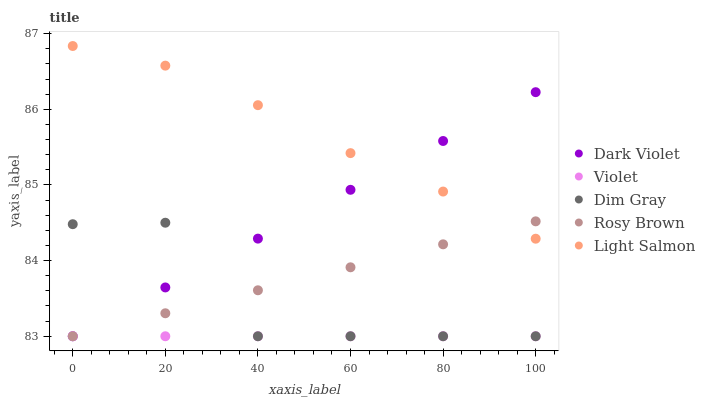Does Violet have the minimum area under the curve?
Answer yes or no. Yes. Does Light Salmon have the maximum area under the curve?
Answer yes or no. Yes. Does Dim Gray have the minimum area under the curve?
Answer yes or no. No. Does Dim Gray have the maximum area under the curve?
Answer yes or no. No. Is Rosy Brown the smoothest?
Answer yes or no. Yes. Is Dim Gray the roughest?
Answer yes or no. Yes. Is Light Salmon the smoothest?
Answer yes or no. No. Is Light Salmon the roughest?
Answer yes or no. No. Does Rosy Brown have the lowest value?
Answer yes or no. Yes. Does Light Salmon have the lowest value?
Answer yes or no. No. Does Light Salmon have the highest value?
Answer yes or no. Yes. Does Dim Gray have the highest value?
Answer yes or no. No. Is Dim Gray less than Light Salmon?
Answer yes or no. Yes. Is Light Salmon greater than Dim Gray?
Answer yes or no. Yes. Does Violet intersect Dark Violet?
Answer yes or no. Yes. Is Violet less than Dark Violet?
Answer yes or no. No. Is Violet greater than Dark Violet?
Answer yes or no. No. Does Dim Gray intersect Light Salmon?
Answer yes or no. No. 